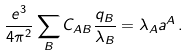Convert formula to latex. <formula><loc_0><loc_0><loc_500><loc_500>\frac { e ^ { 3 } } { 4 \pi ^ { 2 } } \sum _ { B } C _ { A B } \frac { q _ { B } } { \lambda _ { B } } = \lambda _ { A } a ^ { A } \, .</formula> 